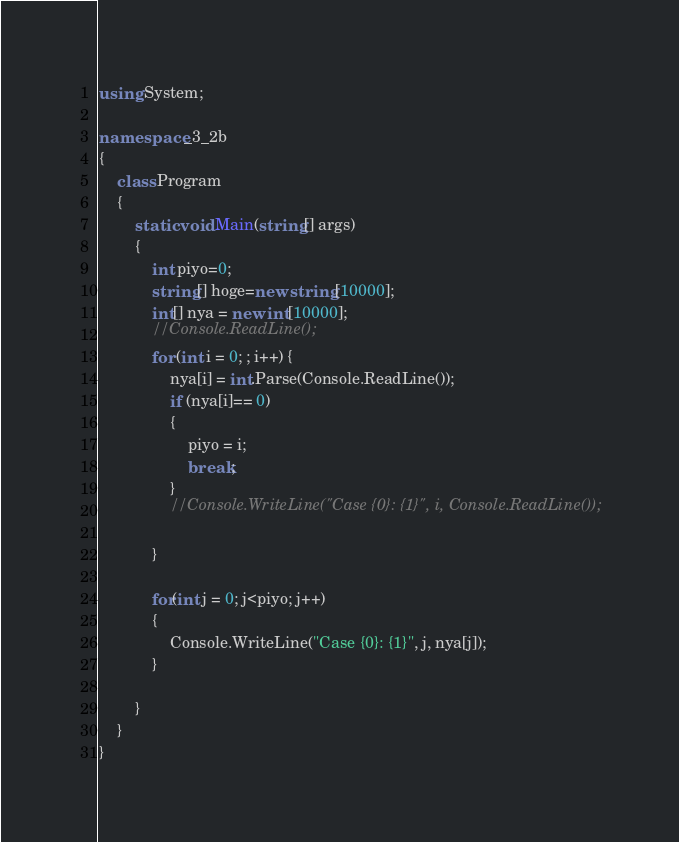Convert code to text. <code><loc_0><loc_0><loc_500><loc_500><_C#_>using System;

namespace _3_2b
{
    class Program
    {
        static void Main(string[] args)
        {
            int piyo=0;
            string[] hoge=new string[10000];
            int[] nya = new int[10000];
            //Console.ReadLine();
            for (int i = 0; ; i++) {
                nya[i] = int.Parse(Console.ReadLine());
                if (nya[i]== 0)
                {
                    piyo = i;
                    break;
                }
                //Console.WriteLine("Case {0}: {1}", i, Console.ReadLine());
             
            }

            for(int j = 0; j<piyo; j++)
            {
                Console.WriteLine("Case {0}: {1}", j, nya[j]);
            }

        }
    }
}

</code> 